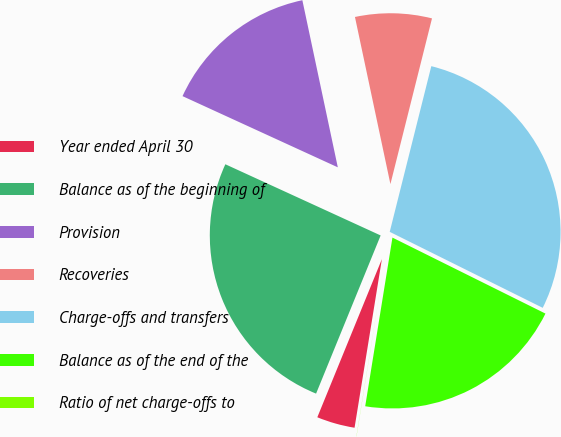Convert chart. <chart><loc_0><loc_0><loc_500><loc_500><pie_chart><fcel>Year ended April 30<fcel>Balance as of the beginning of<fcel>Provision<fcel>Recoveries<fcel>Charge-offs and transfers<fcel>Balance as of the end of the<fcel>Ratio of net charge-offs to<nl><fcel>3.61%<fcel>25.67%<fcel>14.83%<fcel>7.24%<fcel>28.42%<fcel>20.21%<fcel>0.01%<nl></chart> 